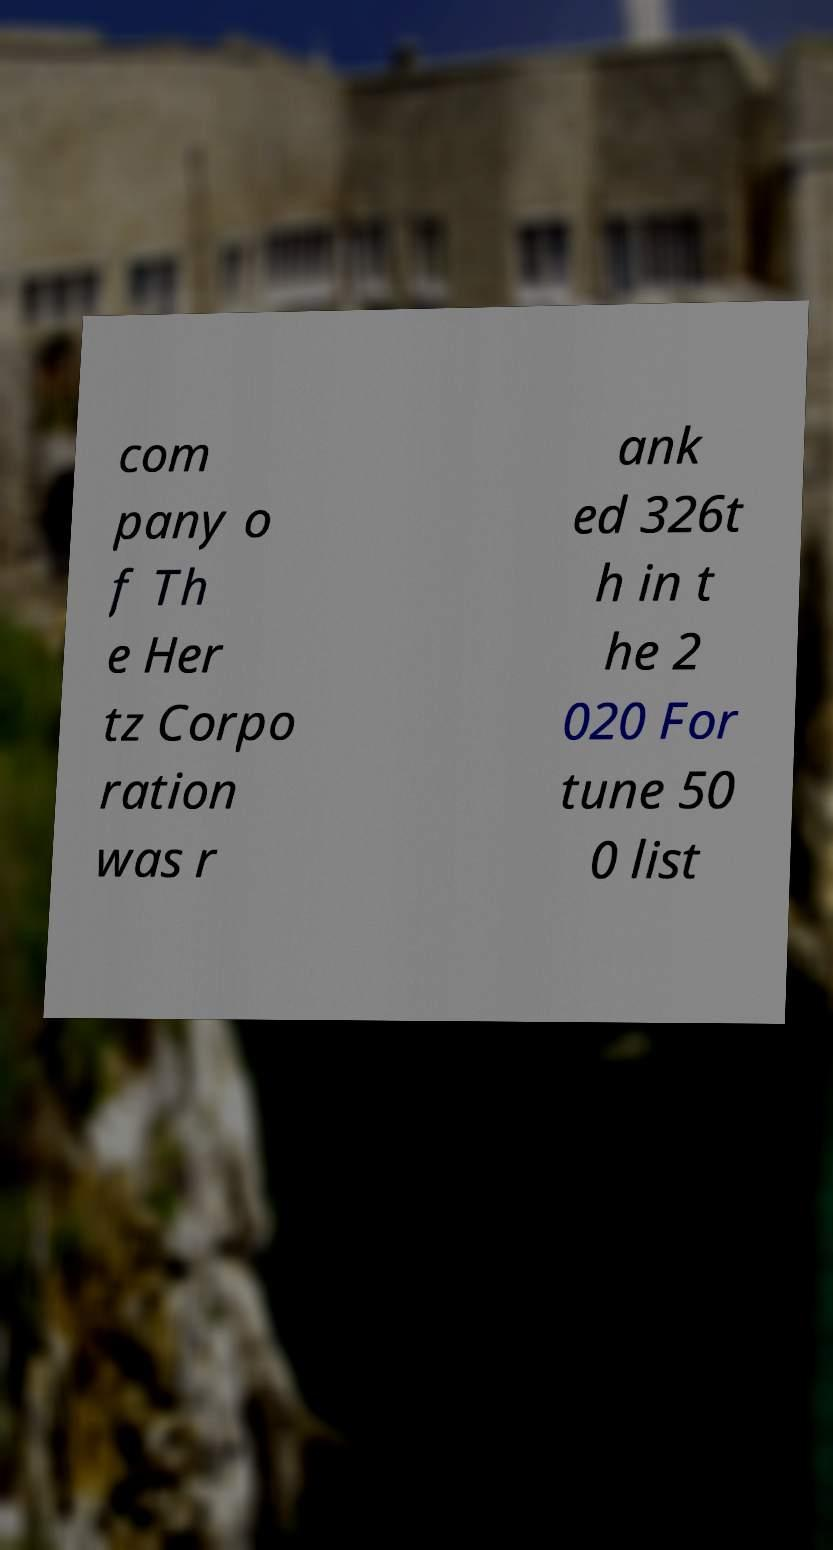Please identify and transcribe the text found in this image. com pany o f Th e Her tz Corpo ration was r ank ed 326t h in t he 2 020 For tune 50 0 list 